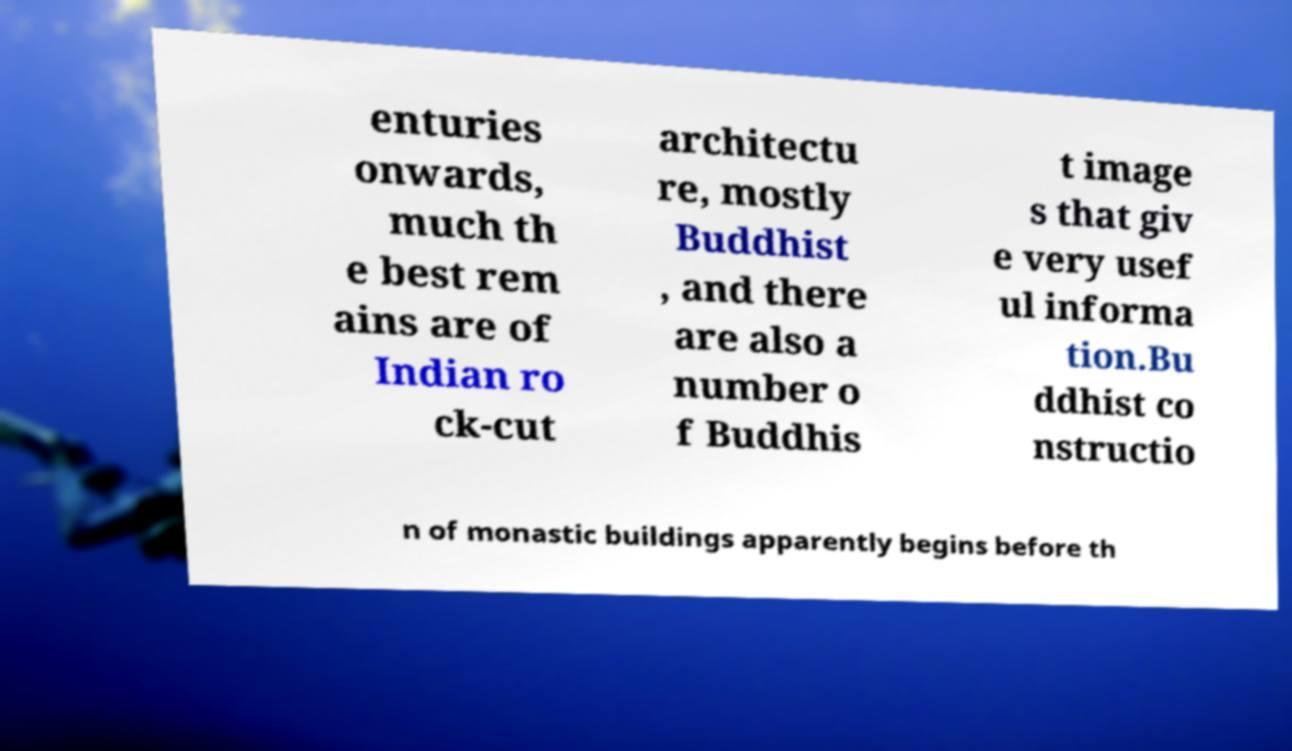Could you extract and type out the text from this image? enturies onwards, much th e best rem ains are of Indian ro ck-cut architectu re, mostly Buddhist , and there are also a number o f Buddhis t image s that giv e very usef ul informa tion.Bu ddhist co nstructio n of monastic buildings apparently begins before th 